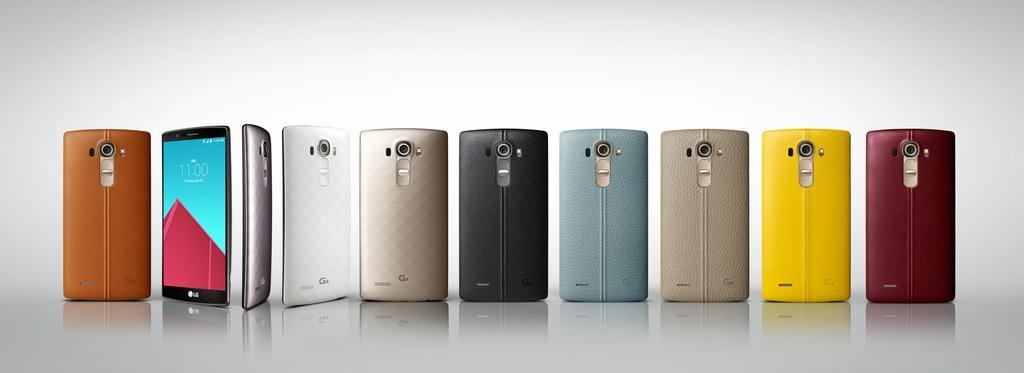What objects are present in the image? There are phones in the image. Can you describe the appearance of the phones? The phones are in different colors. What type of jar is visible in the image? There is no jar present in the image; it only features phones in different colors. 